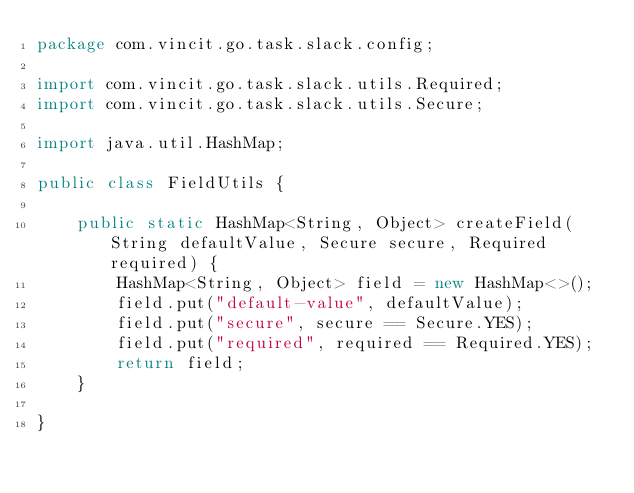Convert code to text. <code><loc_0><loc_0><loc_500><loc_500><_Java_>package com.vincit.go.task.slack.config;

import com.vincit.go.task.slack.utils.Required;
import com.vincit.go.task.slack.utils.Secure;

import java.util.HashMap;

public class FieldUtils {

    public static HashMap<String, Object> createField(String defaultValue, Secure secure, Required required) {
        HashMap<String, Object> field = new HashMap<>();
        field.put("default-value", defaultValue);
        field.put("secure", secure == Secure.YES);
        field.put("required", required == Required.YES);
        return field;
    }

}
</code> 